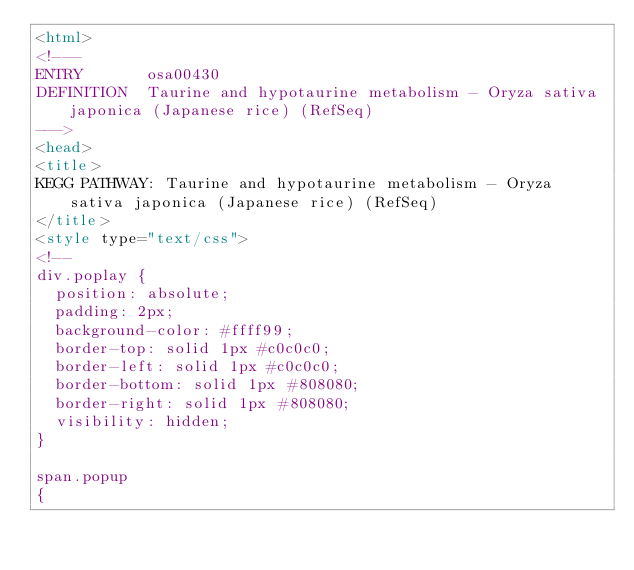Convert code to text. <code><loc_0><loc_0><loc_500><loc_500><_HTML_><html>
<!---
ENTRY       osa00430
DEFINITION  Taurine and hypotaurine metabolism - Oryza sativa japonica (Japanese rice) (RefSeq)
--->
<head>
<title>
KEGG PATHWAY: Taurine and hypotaurine metabolism - Oryza sativa japonica (Japanese rice) (RefSeq)
</title>
<style type="text/css">
<!--
div.poplay {
  position: absolute;
  padding: 2px;
  background-color: #ffff99;
  border-top: solid 1px #c0c0c0;
  border-left: solid 1px #c0c0c0;
  border-bottom: solid 1px #808080;
  border-right: solid 1px #808080;
  visibility: hidden;
}

span.popup
{</code> 